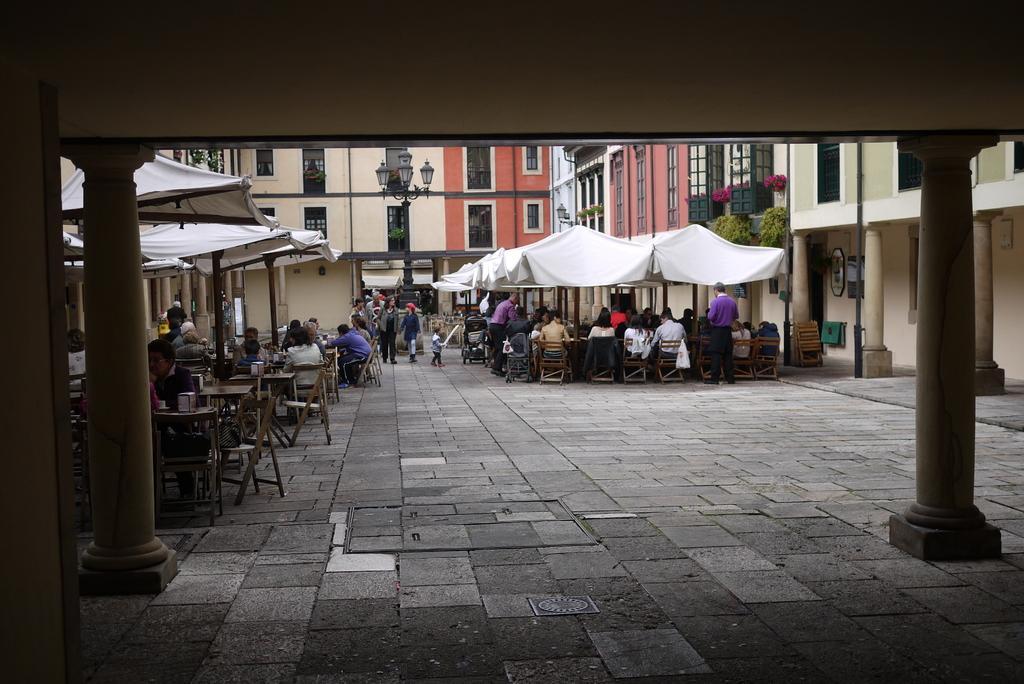In one or two sentences, can you explain what this image depicts? This picture is clicked outside. In the foreground we can see the pillars and some objects. In the center we can see the group of people sitting on the chairs and we can see the group of people walking on the ground. On the right we can see the two people standing on the ground and we can see some objects are placed on the top of the tables and we can see the tents, pillars, buildings, lamp post, wall mounted lamp and many other objects and we can see a stroller. 